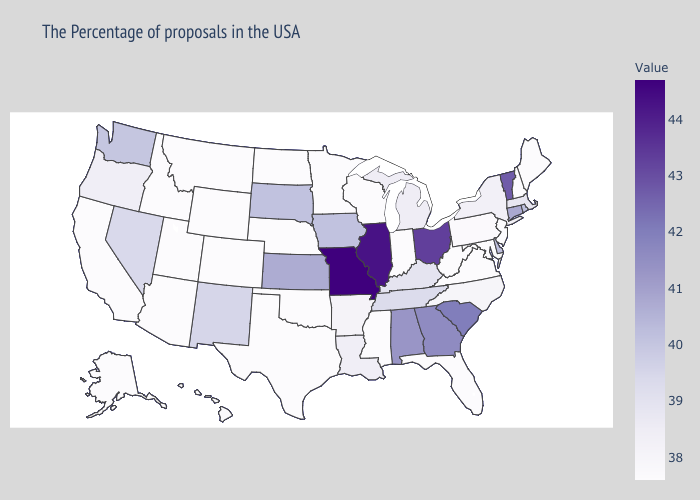Does Georgia have the highest value in the USA?
Answer briefly. No. Does Missouri have the highest value in the USA?
Keep it brief. Yes. Which states hav the highest value in the MidWest?
Short answer required. Missouri. Among the states that border Ohio , which have the highest value?
Concise answer only. Kentucky. Does West Virginia have the lowest value in the South?
Answer briefly. Yes. 